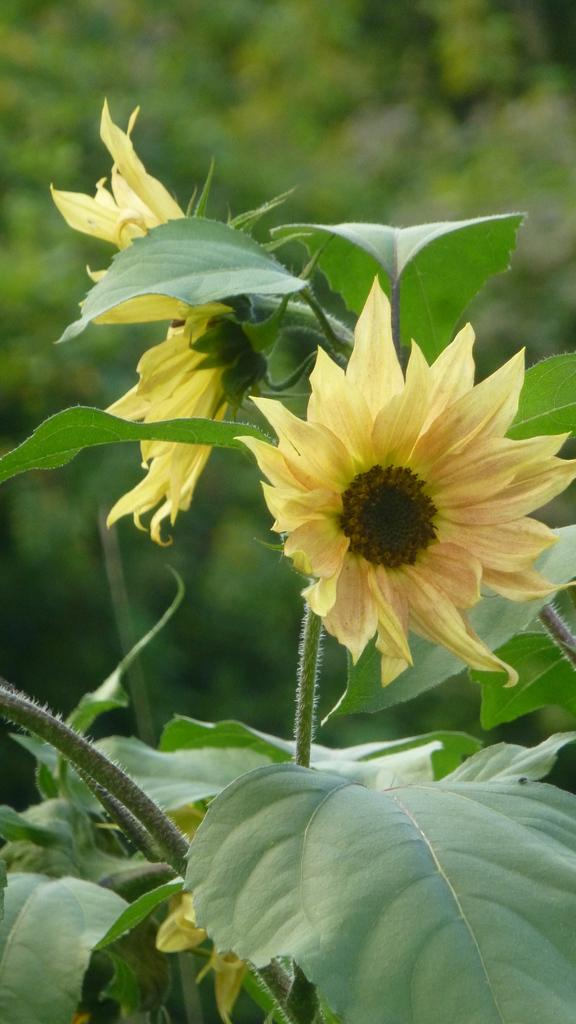What type of plants are visible in the image? There are flowers with leaves in the image. Can you describe the background of the image? The background of the image is blurred. What type of jewel is the creature wearing in the image? There is no creature or jewel present in the image; it only features flowers with leaves and a blurred background. 